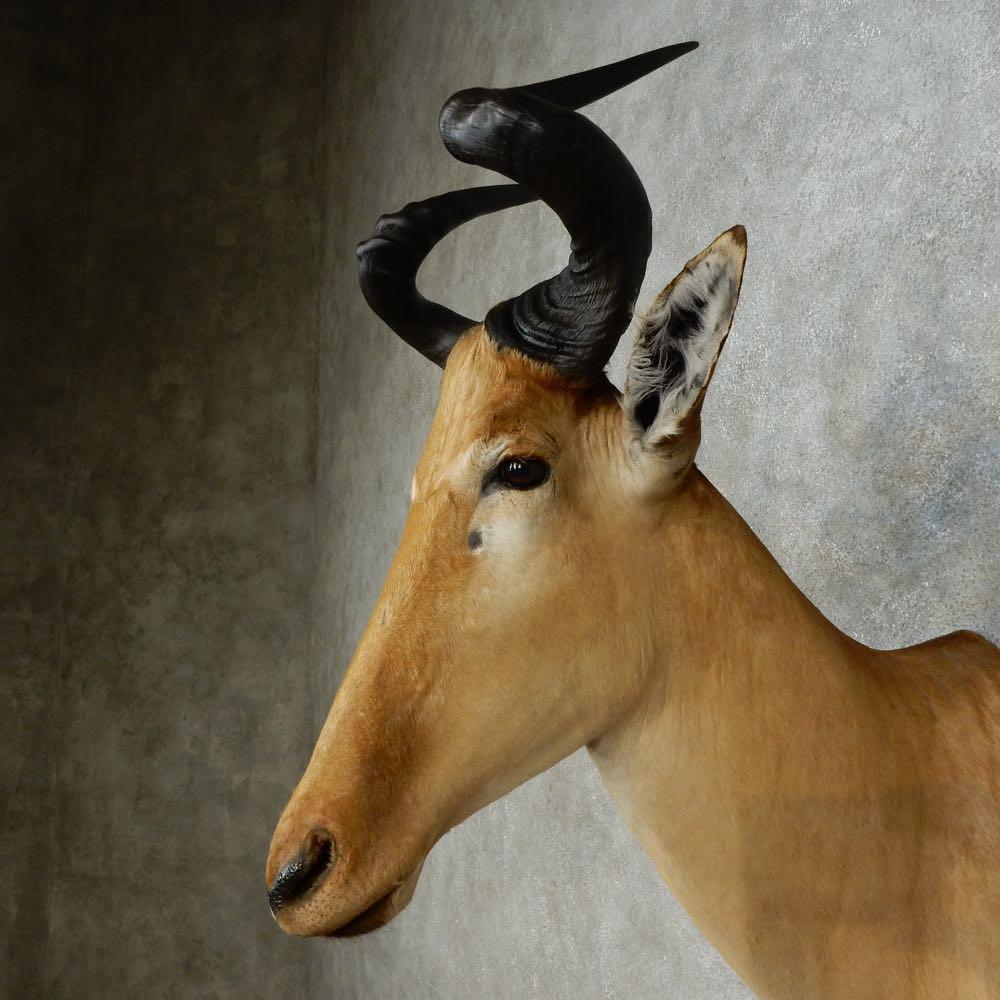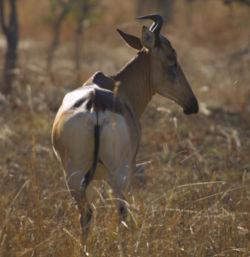The first image is the image on the left, the second image is the image on the right. Evaluate the accuracy of this statement regarding the images: "There are two antelope heads shown without a body.". Is it true? Answer yes or no. No. The first image is the image on the left, the second image is the image on the right. Considering the images on both sides, is "An image shows the head of a horned animal mounted on a knotty wood plank wall." valid? Answer yes or no. No. 